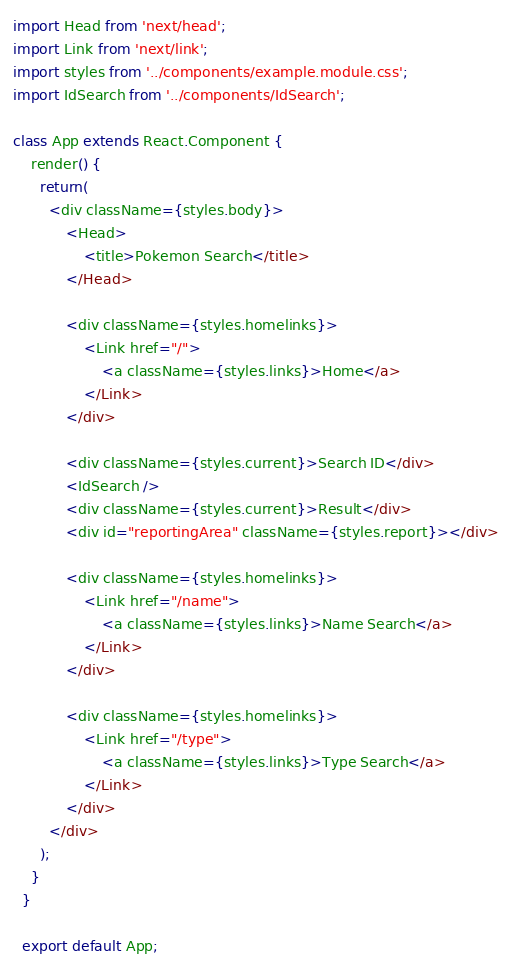Convert code to text. <code><loc_0><loc_0><loc_500><loc_500><_JavaScript_>import Head from 'next/head';
import Link from 'next/link';
import styles from '../components/example.module.css';
import IdSearch from '../components/IdSearch';

class App extends React.Component {
    render() {
      return(
        <div className={styles.body}>
            <Head>
                <title>Pokemon Search</title>
            </Head>

            <div className={styles.homelinks}>
                <Link href="/">
                    <a className={styles.links}>Home</a>
                </Link>
            </div>

            <div className={styles.current}>Search ID</div>
            <IdSearch />
            <div className={styles.current}>Result</div>
            <div id="reportingArea" className={styles.report}></div>
            
            <div className={styles.homelinks}>
                <Link href="/name">
                    <a className={styles.links}>Name Search</a>
                </Link>
            </div>

            <div className={styles.homelinks}>
                <Link href="/type">
                    <a className={styles.links}>Type Search</a>
                </Link>
            </div>
        </div>
      );
    }
  }
  
  export default App;</code> 